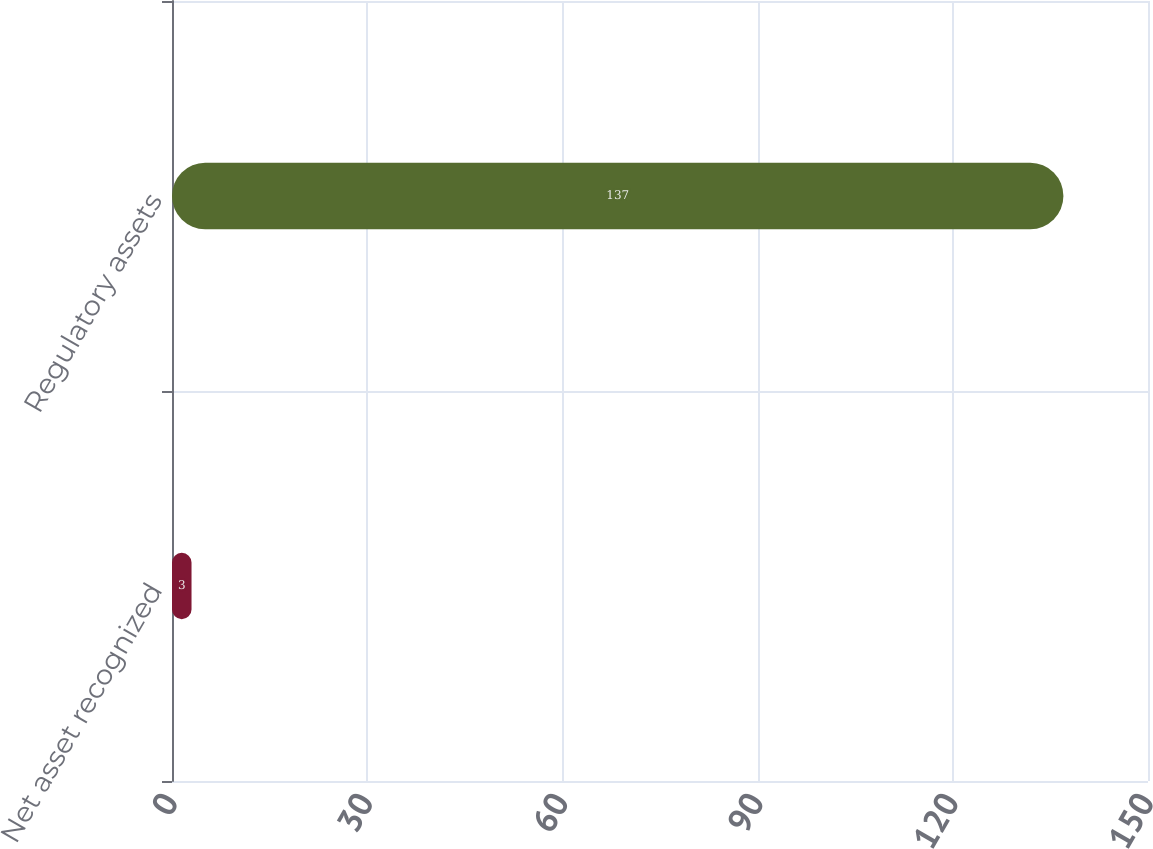Convert chart. <chart><loc_0><loc_0><loc_500><loc_500><bar_chart><fcel>Net asset recognized<fcel>Regulatory assets<nl><fcel>3<fcel>137<nl></chart> 